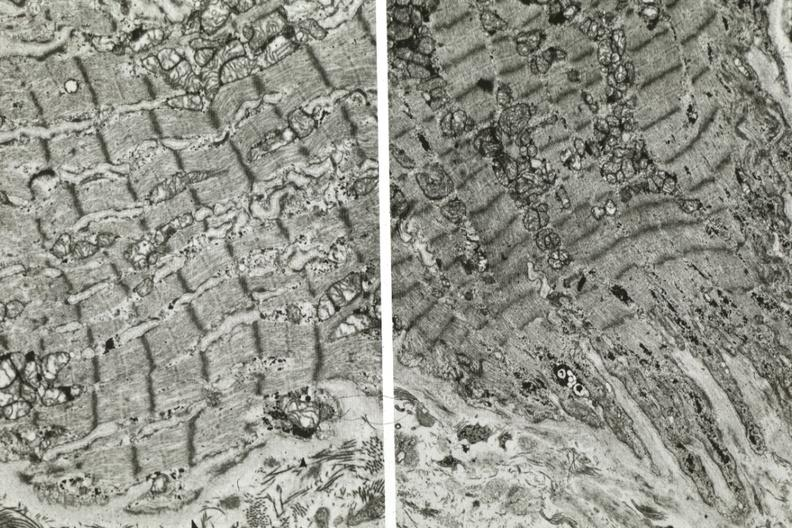does atrophy show dilated sarcoplasmic reticulum?
Answer the question using a single word or phrase. No 